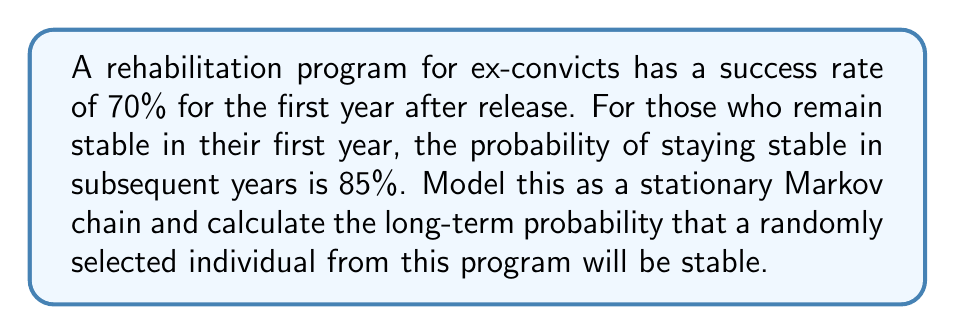Teach me how to tackle this problem. Let's approach this step-by-step:

1) First, we need to define our Markov chain. Let's have two states:
   S: Stable
   U: Unstable

2) We can represent our transition probabilities as a matrix:

   $$P = \begin{bmatrix}
   0.85 & 0.15 \\
   0.70 & 0.30
   \end{bmatrix}$$

   Where $P_{ij}$ is the probability of transitioning from state i to state j.

3) For a stationary Markov chain, the long-term probabilities $\pi = [\pi_S, \pi_U]$ satisfy the equation:

   $$\pi = \pi P$$

4) This gives us the system of equations:

   $$\pi_S = 0.85\pi_S + 0.70\pi_U$$
   $$\pi_U = 0.15\pi_S + 0.30\pi_U$$

5) We also know that $\pi_S + \pi_U = 1$

6) Substituting $\pi_U = 1 - \pi_S$ into the first equation:

   $$\pi_S = 0.85\pi_S + 0.70(1 - \pi_S)$$

7) Solving this equation:

   $$\pi_S = 0.85\pi_S + 0.70 - 0.70\pi_S$$
   $$0.15\pi_S = 0.70$$
   $$\pi_S = \frac{0.70}{0.15} = \frac{14}{3} \approx 0.8235$$

8) Therefore, $\pi_U = 1 - \pi_S \approx 0.1765$

The long-term probability that a randomly selected individual will be stable is approximately 0.8235 or 82.35%.
Answer: 0.8235 